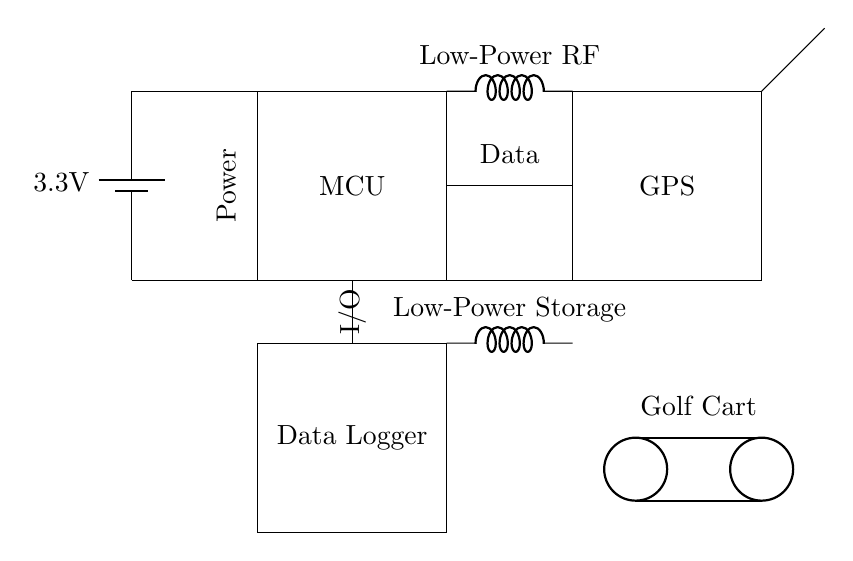What is the voltage of the power supply in this circuit? The power supply is represented by the battery symbol at the top left corner, and it shows a voltage of 3.3V.
Answer: 3.3V What components are connected to the microcontroller? The microcontroller has connections leading to the power supply, GPS module, and data logger. The lines indicate that it receives power and communicates with these components.
Answer: Power supply, GPS module, Data Logger What type of circuit is this? This circuit is a low-power hybrid circuit designed for GPS tracking and data logging purposes in golf carts, as indicated by its components and layout.
Answer: Low-power hybrid circuit What is the purpose of the cute inductors in this circuit? The cute inductors are labeled as Low-Power RF and Low-Power Storage. This suggests that one inductor is used for radio frequency operations related to GPS, and the other for energy storage, optimizing power usage in the circuit.
Answer: Low-Power RF and Low-Power Storage How many components are physically represented in the circuit diagram? By counting each rectangle, battery, and antenna, there are a total of six distinct components visible in the diagram: one battery, one microcontroller, one GPS module, one data logger, and two inductors.
Answer: Six components What is the function of the antenna in this circuit? The antenna is connected to the GPS module, which suggests its purpose is to transmit or receive GPS signals, thereby enabling location tracking for the golf cart.
Answer: Communication What is the significance of the labeled connections such as "Power" and "I/O"? These labels indicate the function of the corresponding connections—'Power' provides electrical energy to the components while 'I/O' denotes input/output communication links between the microcontroller and the data logger, emphasizing data transfer.
Answer: Function-oriented connections 